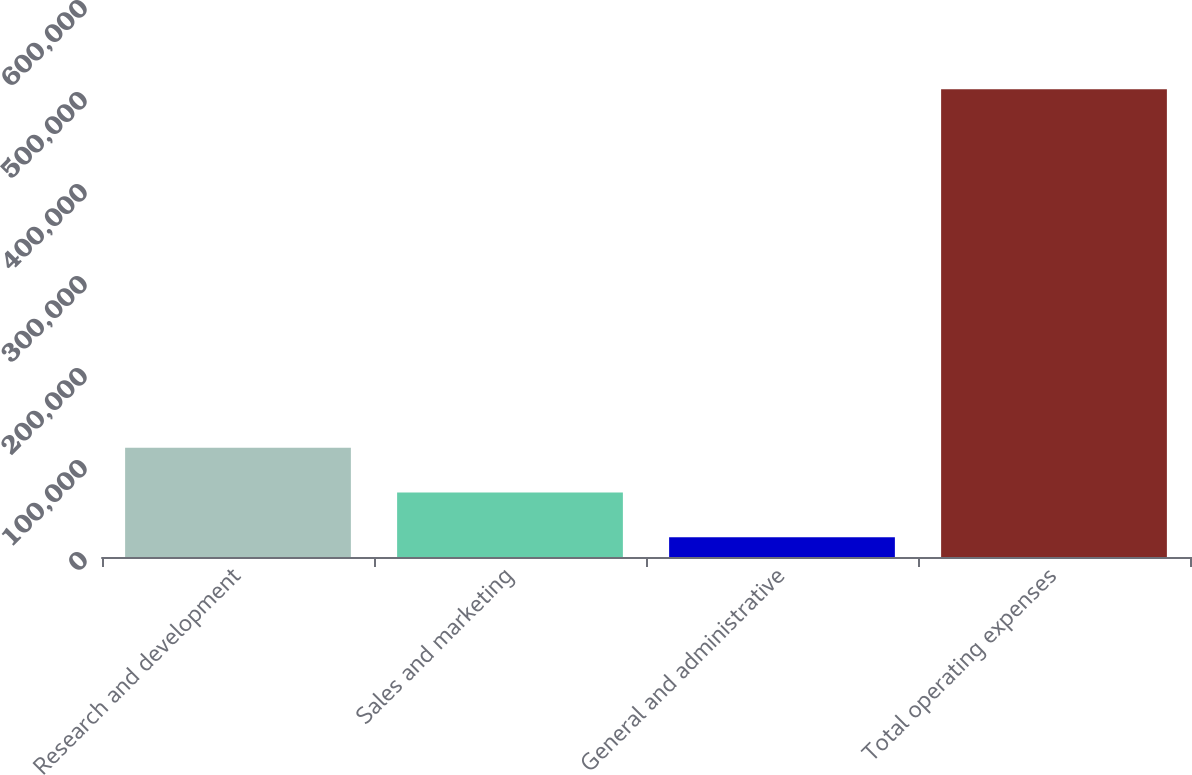Convert chart. <chart><loc_0><loc_0><loc_500><loc_500><bar_chart><fcel>Research and development<fcel>Sales and marketing<fcel>General and administrative<fcel>Total operating expenses<nl><fcel>118809<fcel>70093.5<fcel>21378<fcel>508533<nl></chart> 